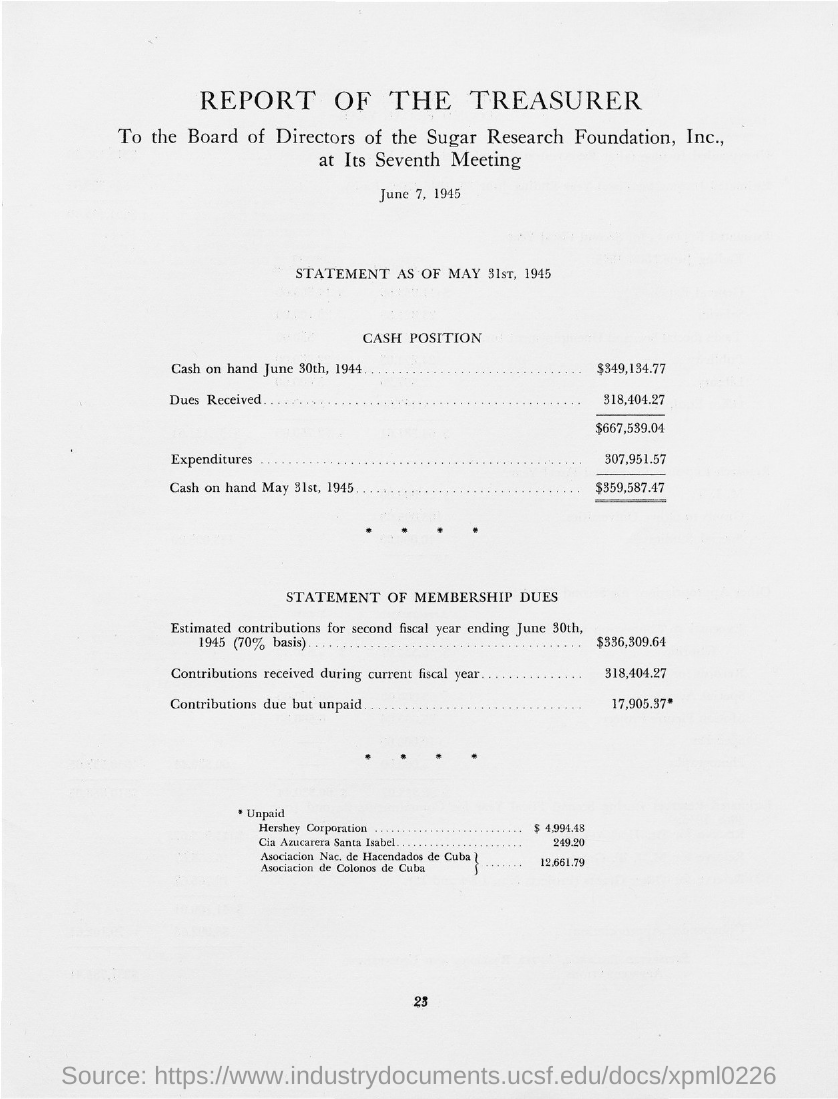Draw attention to some important aspects in this diagram. The document is dated June 7, 1945. The amount received as dues is 318,404.27 dollars. The document concerns a report of the treasurer. 